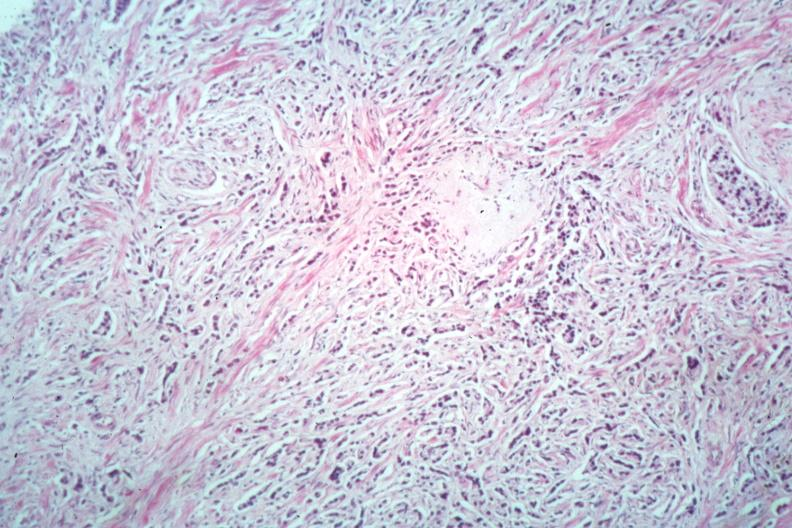what is present?
Answer the question using a single word or phrase. Prostate 